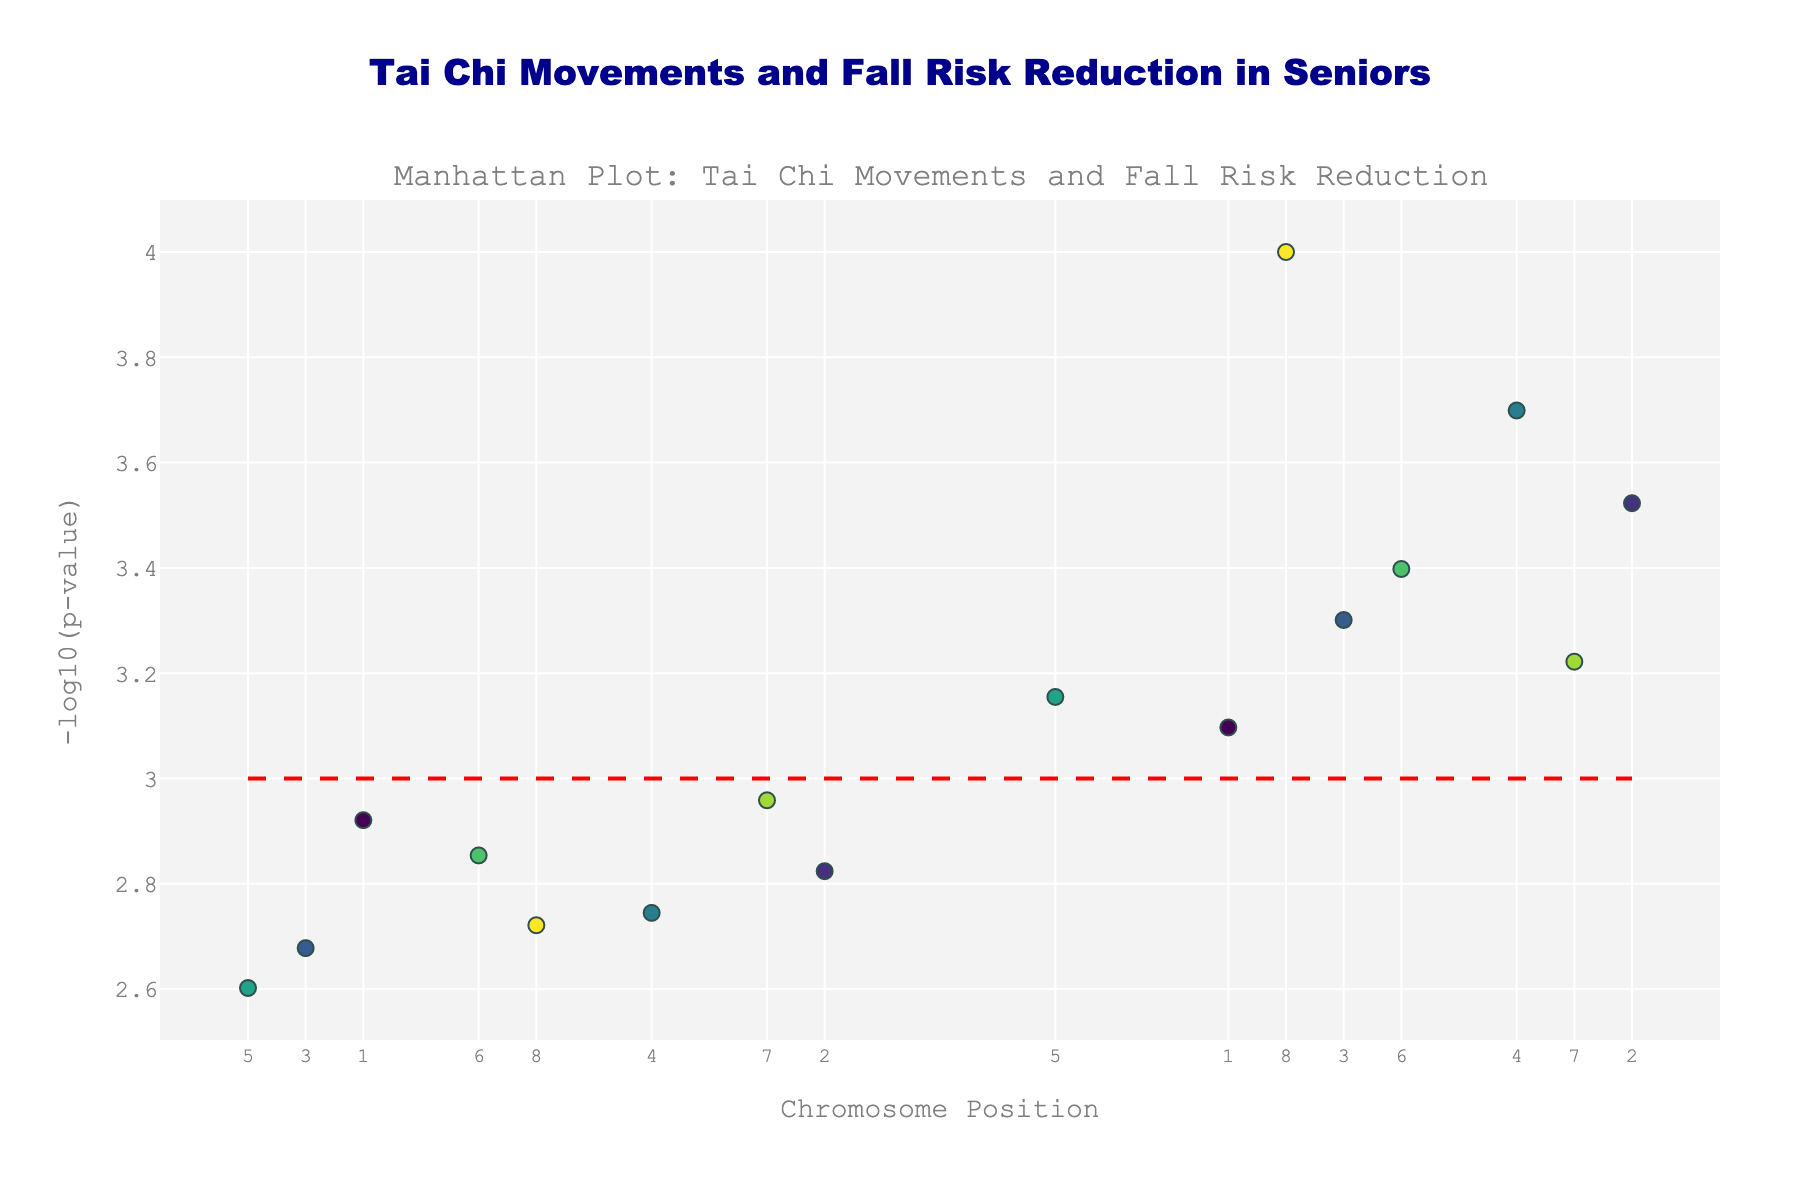How many total tai chi movements are represented in the plot? Count the number of unique text labels (movements) in the scatter plot.
Answer: 16 What is the title of the plot? Read the main title text at the top of the plot.
Answer: Tai Chi Movements and Fall Risk Reduction in Seniors What is the maximum value of the y-axis? Identify the highest point reached by the blue markers in the scatter plot.
Answer: 4.0 Which tai chi movement has the smallest p-value? Find the movement associated with the point at the highest y-value, which corresponds to the lowest p-value.
Answer: High Pat on Horse What is the visual indication of different chromosomes in the plot? Identify the color differences in the markers of the scatter plot, which represent different chromosomes.
Answer: Different colors How many data points have a p-value below 0.001? Count the number of points that lie above the red dashed line, which represents -log10(0.001).
Answer: 8 Compare the p-values of "Fan Through Back" and "Brush Knee and Twist Step." Which one has a smaller p-value? Identify the y-values for both points. Higher -log10(p-value) means smaller p-value.
Answer: Brush Knee and Twist Step Which movement on chromosome 4 has the lowest p-value? Identify the points on chromosome 4 and determine which one has the highest y-value (lowest p-value).
Answer: Repulse Monkey What is the average -log10(p-value) of the movements on chromosome 3? Find the y-values for movements on chromosome 3, sum them up, and divide by the number of those points.
Answer: (3.68 + 3.30) / 2 = 3.49 Is there any movement with a p-value exactly at 0.001? Check if there is a data point at y = -log10(0.001).
Answer: No 